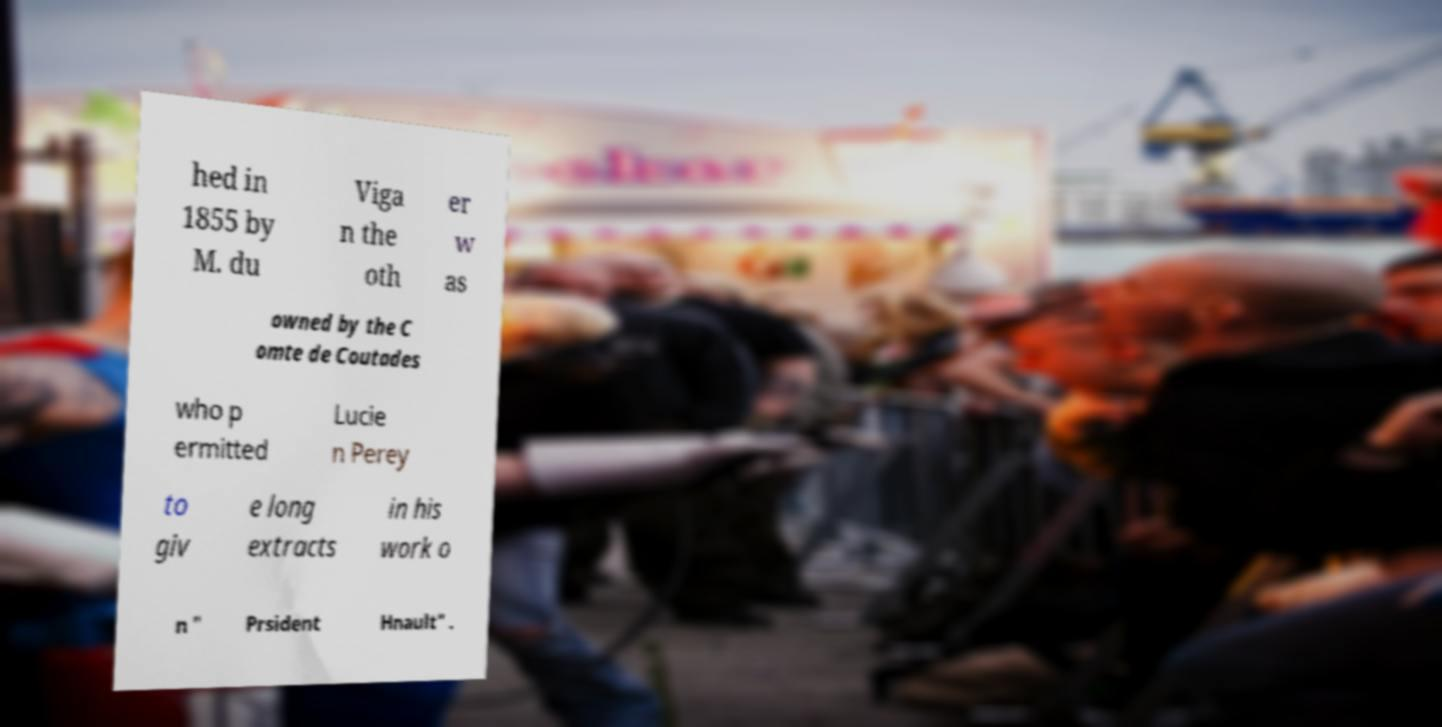Please read and relay the text visible in this image. What does it say? hed in 1855 by M. du Viga n the oth er w as owned by the C omte de Coutades who p ermitted Lucie n Perey to giv e long extracts in his work o n " Prsident Hnault" . 